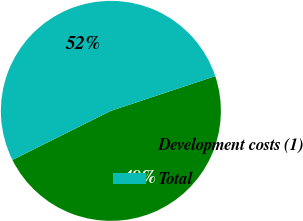<chart> <loc_0><loc_0><loc_500><loc_500><pie_chart><fcel>Development costs (1)<fcel>Total<nl><fcel>47.76%<fcel>52.24%<nl></chart> 